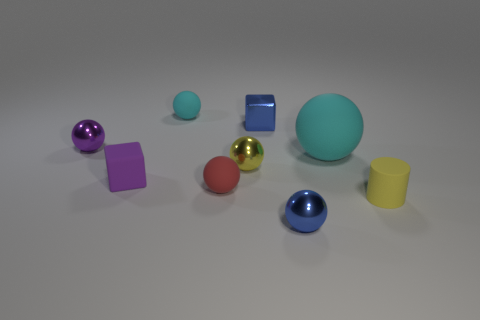There is a small object that is the same color as the small matte cube; what material is it?
Provide a short and direct response. Metal. There is a matte object that is both behind the tiny rubber block and on the left side of the small yellow metal sphere; what is its shape?
Your answer should be compact. Sphere. The tiny cylinder that is the same material as the large cyan thing is what color?
Your response must be concise. Yellow. Are there an equal number of large matte balls in front of the matte block and spheres?
Provide a succinct answer. No. What shape is the red matte thing that is the same size as the blue shiny block?
Your answer should be compact. Sphere. How many other objects are there of the same shape as the small yellow metallic thing?
Keep it short and to the point. 5. There is a yellow ball; does it have the same size as the cyan rubber ball that is on the right side of the small blue shiny sphere?
Your response must be concise. No. How many things are balls in front of the red matte ball or big brown rubber cylinders?
Offer a very short reply. 1. What shape is the small blue object behind the small yellow shiny ball?
Offer a very short reply. Cube. Are there an equal number of small blue objects in front of the blue cube and spheres in front of the large cyan sphere?
Make the answer very short. No. 